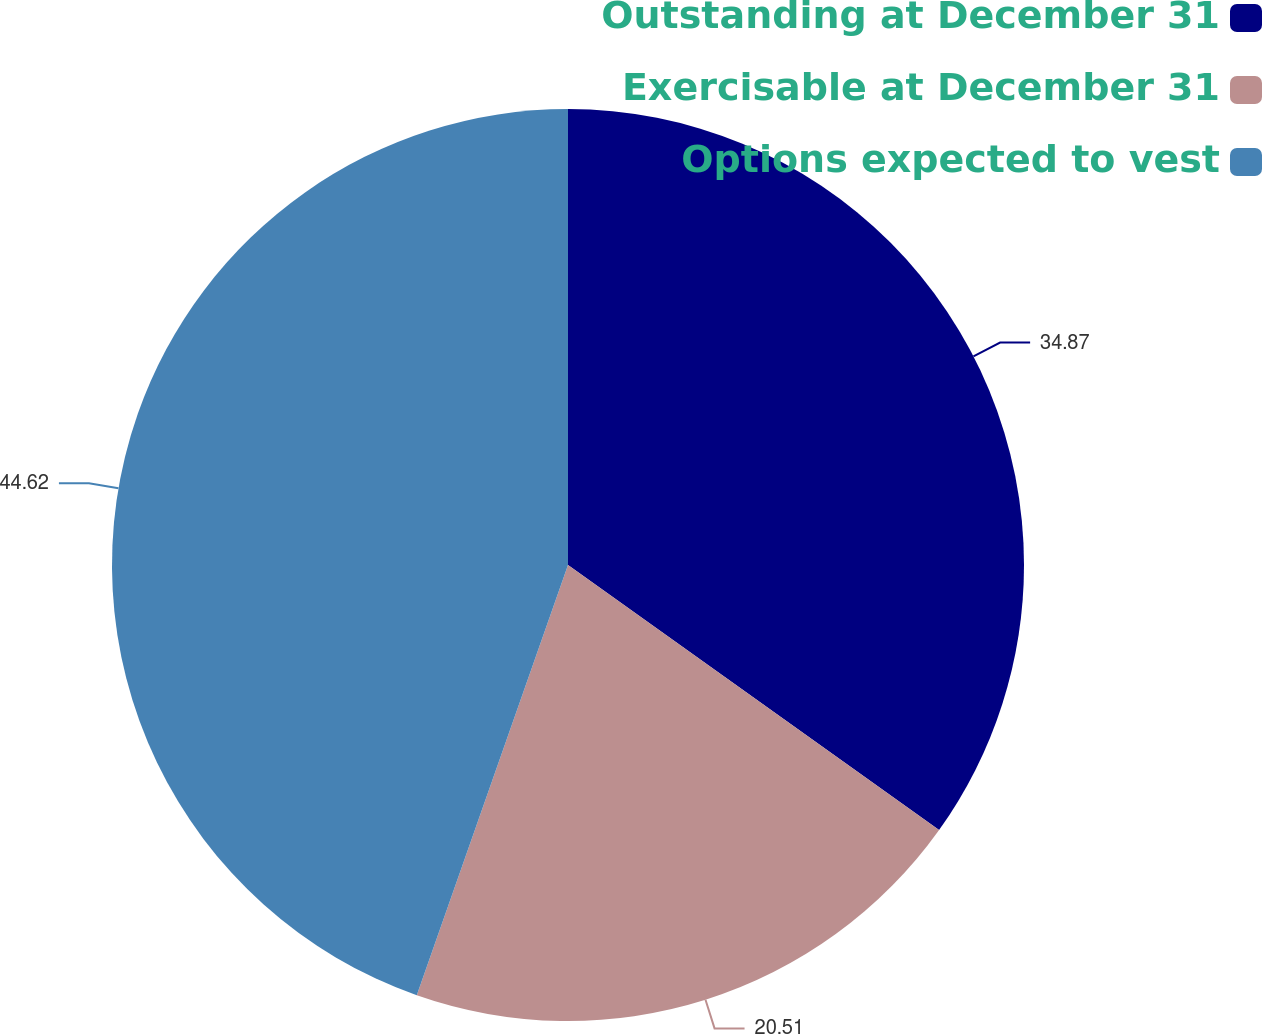Convert chart. <chart><loc_0><loc_0><loc_500><loc_500><pie_chart><fcel>Outstanding at December 31<fcel>Exercisable at December 31<fcel>Options expected to vest<nl><fcel>34.87%<fcel>20.51%<fcel>44.62%<nl></chart> 